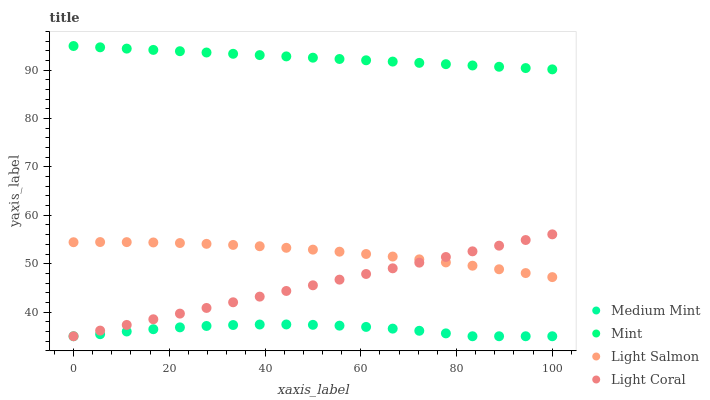Does Medium Mint have the minimum area under the curve?
Answer yes or no. Yes. Does Mint have the maximum area under the curve?
Answer yes or no. Yes. Does Light Coral have the minimum area under the curve?
Answer yes or no. No. Does Light Coral have the maximum area under the curve?
Answer yes or no. No. Is Light Coral the smoothest?
Answer yes or no. Yes. Is Medium Mint the roughest?
Answer yes or no. Yes. Is Light Salmon the smoothest?
Answer yes or no. No. Is Light Salmon the roughest?
Answer yes or no. No. Does Medium Mint have the lowest value?
Answer yes or no. Yes. Does Light Salmon have the lowest value?
Answer yes or no. No. Does Mint have the highest value?
Answer yes or no. Yes. Does Light Coral have the highest value?
Answer yes or no. No. Is Light Salmon less than Mint?
Answer yes or no. Yes. Is Mint greater than Medium Mint?
Answer yes or no. Yes. Does Light Coral intersect Light Salmon?
Answer yes or no. Yes. Is Light Coral less than Light Salmon?
Answer yes or no. No. Is Light Coral greater than Light Salmon?
Answer yes or no. No. Does Light Salmon intersect Mint?
Answer yes or no. No. 